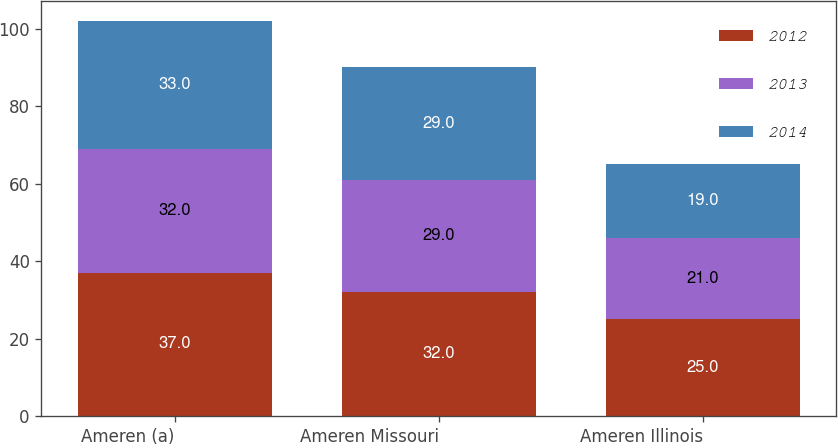Convert chart. <chart><loc_0><loc_0><loc_500><loc_500><stacked_bar_chart><ecel><fcel>Ameren (a)<fcel>Ameren Missouri<fcel>Ameren Illinois<nl><fcel>2012<fcel>37<fcel>32<fcel>25<nl><fcel>2013<fcel>32<fcel>29<fcel>21<nl><fcel>2014<fcel>33<fcel>29<fcel>19<nl></chart> 